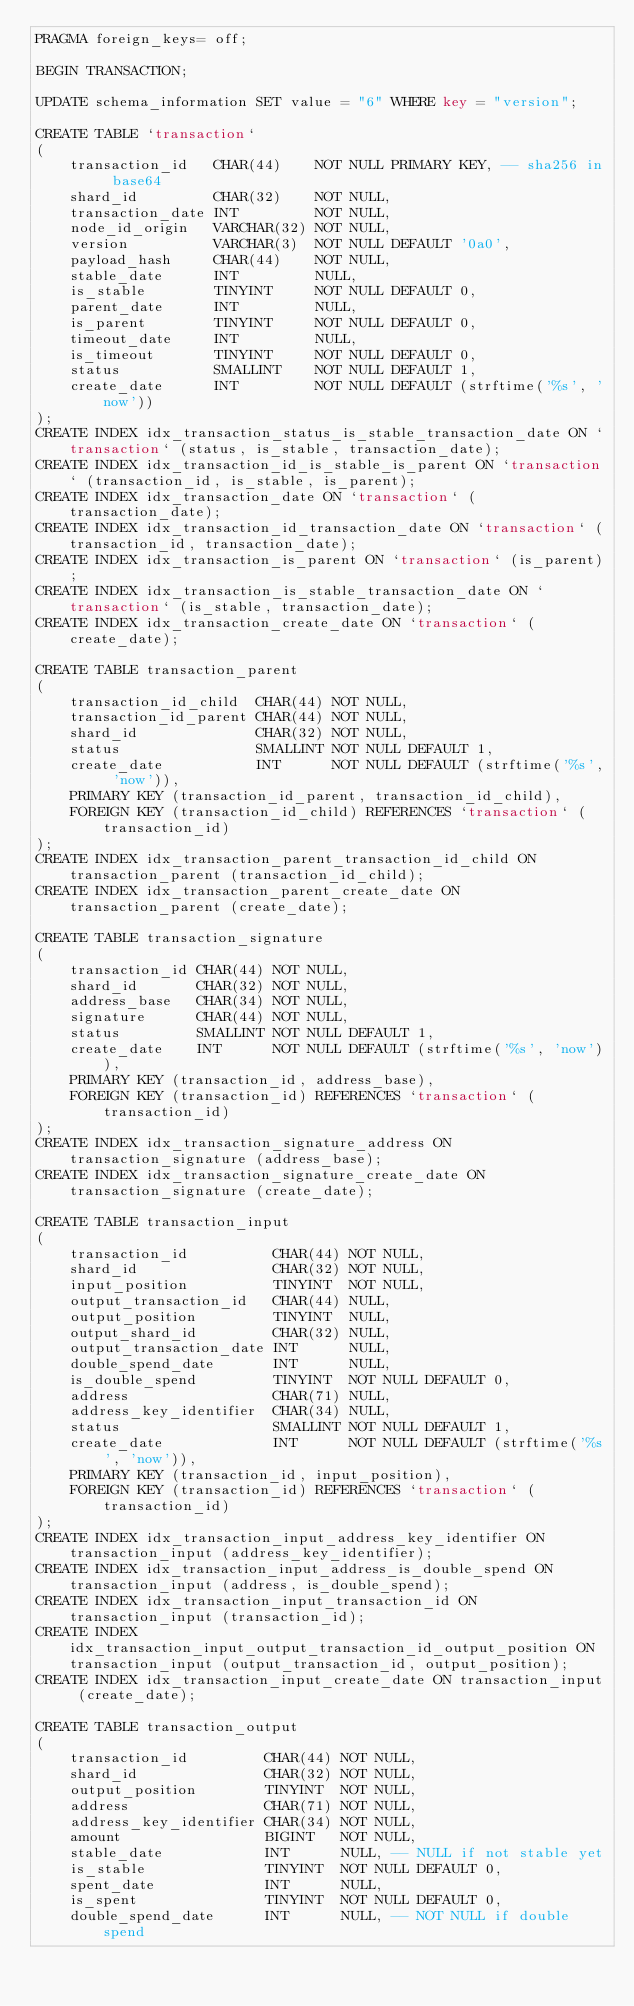Convert code to text. <code><loc_0><loc_0><loc_500><loc_500><_SQL_>PRAGMA foreign_keys= off;

BEGIN TRANSACTION;

UPDATE schema_information SET value = "6" WHERE key = "version";

CREATE TABLE `transaction`
(
    transaction_id   CHAR(44)    NOT NULL PRIMARY KEY, -- sha256 in base64
    shard_id         CHAR(32)    NOT NULL,
    transaction_date INT         NOT NULL,
    node_id_origin   VARCHAR(32) NOT NULL,
    version          VARCHAR(3)  NOT NULL DEFAULT '0a0',
    payload_hash     CHAR(44)    NOT NULL,
    stable_date      INT         NULL,
    is_stable        TINYINT     NOT NULL DEFAULT 0,
    parent_date      INT         NULL,
    is_parent        TINYINT     NOT NULL DEFAULT 0,
    timeout_date     INT         NULL,
    is_timeout       TINYINT     NOT NULL DEFAULT 0,
    status           SMALLINT    NOT NULL DEFAULT 1,
    create_date      INT         NOT NULL DEFAULT (strftime('%s', 'now'))
);
CREATE INDEX idx_transaction_status_is_stable_transaction_date ON `transaction` (status, is_stable, transaction_date);
CREATE INDEX idx_transaction_id_is_stable_is_parent ON `transaction` (transaction_id, is_stable, is_parent);
CREATE INDEX idx_transaction_date ON `transaction` (transaction_date);
CREATE INDEX idx_transaction_id_transaction_date ON `transaction` (transaction_id, transaction_date);
CREATE INDEX idx_transaction_is_parent ON `transaction` (is_parent);
CREATE INDEX idx_transaction_is_stable_transaction_date ON `transaction` (is_stable, transaction_date);
CREATE INDEX idx_transaction_create_date ON `transaction` (create_date);

CREATE TABLE transaction_parent
(
    transaction_id_child  CHAR(44) NOT NULL,
    transaction_id_parent CHAR(44) NOT NULL,
    shard_id              CHAR(32) NOT NULL,
    status                SMALLINT NOT NULL DEFAULT 1,
    create_date           INT      NOT NULL DEFAULT (strftime('%s', 'now')),
    PRIMARY KEY (transaction_id_parent, transaction_id_child),
    FOREIGN KEY (transaction_id_child) REFERENCES `transaction` (transaction_id)
);
CREATE INDEX idx_transaction_parent_transaction_id_child ON transaction_parent (transaction_id_child);
CREATE INDEX idx_transaction_parent_create_date ON transaction_parent (create_date);

CREATE TABLE transaction_signature
(
    transaction_id CHAR(44) NOT NULL,
    shard_id       CHAR(32) NOT NULL,
    address_base   CHAR(34) NOT NULL,
    signature      CHAR(44) NOT NULL,
    status         SMALLINT NOT NULL DEFAULT 1,
    create_date    INT      NOT NULL DEFAULT (strftime('%s', 'now')),
    PRIMARY KEY (transaction_id, address_base),
    FOREIGN KEY (transaction_id) REFERENCES `transaction` (transaction_id)
);
CREATE INDEX idx_transaction_signature_address ON transaction_signature (address_base);
CREATE INDEX idx_transaction_signature_create_date ON transaction_signature (create_date);

CREATE TABLE transaction_input
(
    transaction_id          CHAR(44) NOT NULL,
    shard_id                CHAR(32) NOT NULL,
    input_position          TINYINT  NOT NULL,
    output_transaction_id   CHAR(44) NULL,
    output_position         TINYINT  NULL,
    output_shard_id         CHAR(32) NULL,
    output_transaction_date INT      NULL,
    double_spend_date       INT      NULL,
    is_double_spend         TINYINT  NOT NULL DEFAULT 0,
    address                 CHAR(71) NULL,
    address_key_identifier  CHAR(34) NULL,
    status                  SMALLINT NOT NULL DEFAULT 1,
    create_date             INT      NOT NULL DEFAULT (strftime('%s', 'now')),
    PRIMARY KEY (transaction_id, input_position),
    FOREIGN KEY (transaction_id) REFERENCES `transaction` (transaction_id)
);
CREATE INDEX idx_transaction_input_address_key_identifier ON transaction_input (address_key_identifier);
CREATE INDEX idx_transaction_input_address_is_double_spend ON transaction_input (address, is_double_spend);
CREATE INDEX idx_transaction_input_transaction_id ON transaction_input (transaction_id);
CREATE INDEX idx_transaction_input_output_transaction_id_output_position ON transaction_input (output_transaction_id, output_position);
CREATE INDEX idx_transaction_input_create_date ON transaction_input (create_date);

CREATE TABLE transaction_output
(
    transaction_id         CHAR(44) NOT NULL,
    shard_id               CHAR(32) NOT NULL,
    output_position        TINYINT  NOT NULL,
    address                CHAR(71) NOT NULL,
    address_key_identifier CHAR(34) NOT NULL,
    amount                 BIGINT   NOT NULL,
    stable_date            INT      NULL, -- NULL if not stable yet
    is_stable              TINYINT  NOT NULL DEFAULT 0,
    spent_date             INT      NULL,
    is_spent               TINYINT  NOT NULL DEFAULT 0,
    double_spend_date      INT      NULL, -- NOT NULL if double spend</code> 